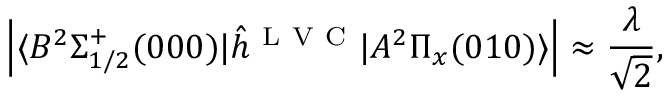Convert formula to latex. <formula><loc_0><loc_0><loc_500><loc_500>\left | \langle B ^ { 2 } \Sigma _ { 1 / 2 } ^ { + } ( 0 0 0 ) | \hat { h } ^ { L V C } | A ^ { 2 } \Pi _ { x } ( 0 1 0 ) \rangle \right | \approx \frac { \lambda } { \sqrt { 2 } } ,</formula> 